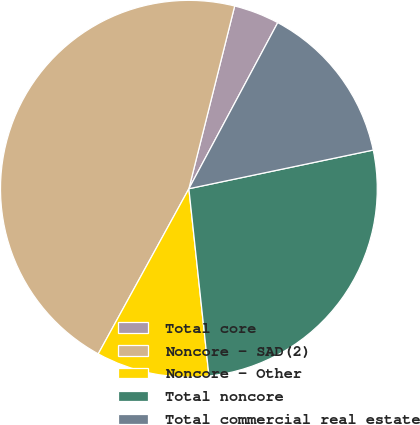Convert chart. <chart><loc_0><loc_0><loc_500><loc_500><pie_chart><fcel>Total core<fcel>Noncore - SAD(2)<fcel>Noncore - Other<fcel>Total noncore<fcel>Total commercial real estate<nl><fcel>3.91%<fcel>45.92%<fcel>9.69%<fcel>26.59%<fcel>13.89%<nl></chart> 